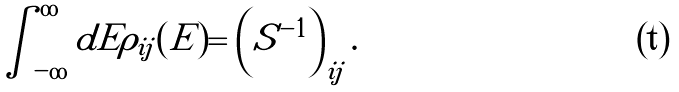Convert formula to latex. <formula><loc_0><loc_0><loc_500><loc_500>\int _ { - \infty } ^ { \infty } d E \rho _ { i j } ( E ) = \left ( S ^ { - 1 } \right ) _ { i j } .</formula> 